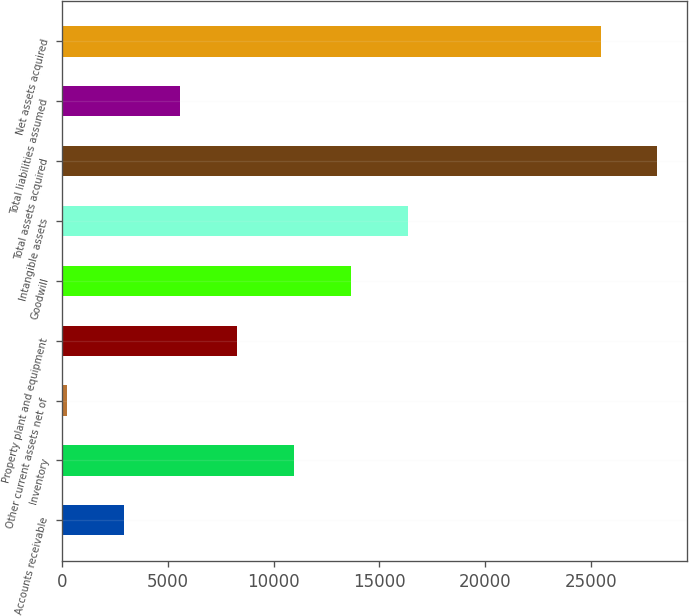Convert chart to OTSL. <chart><loc_0><loc_0><loc_500><loc_500><bar_chart><fcel>Accounts receivable<fcel>Inventory<fcel>Other current assets net of<fcel>Property plant and equipment<fcel>Goodwill<fcel>Intangible assets<fcel>Total assets acquired<fcel>Total liabilities assumed<fcel>Net assets acquired<nl><fcel>2916.6<fcel>10970.4<fcel>232<fcel>8285.8<fcel>13655<fcel>16339.6<fcel>28129.6<fcel>5601.2<fcel>25445<nl></chart> 